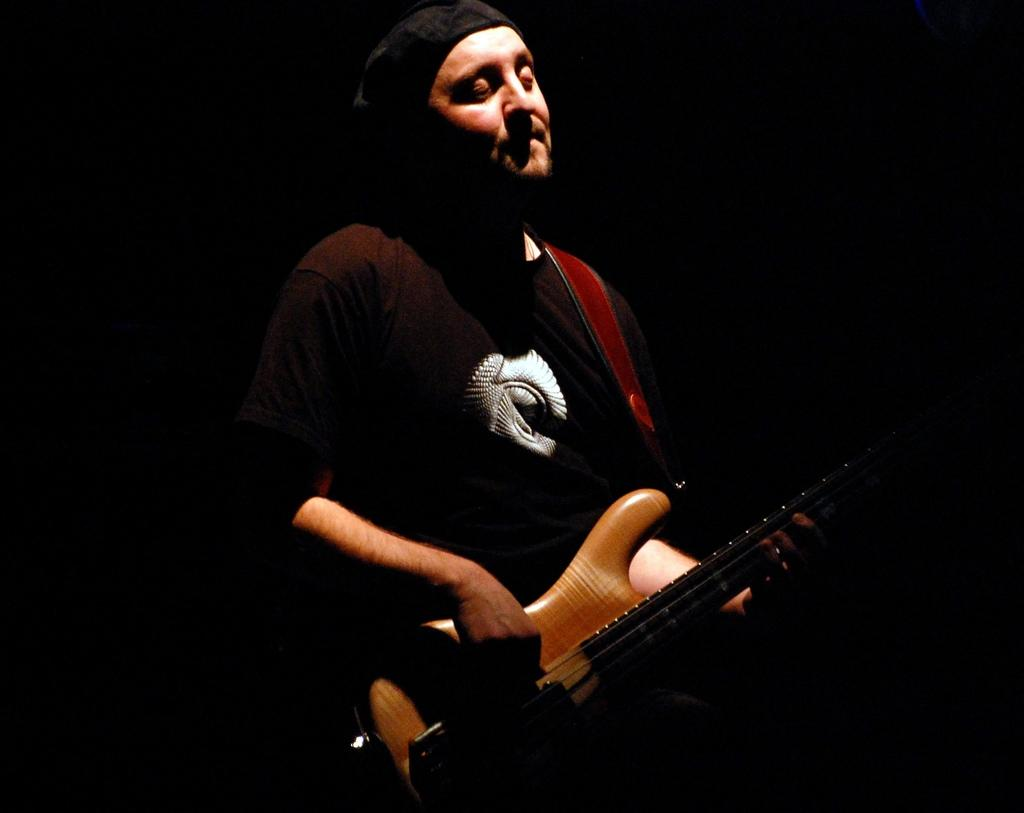What is the main subject of the image? There is a person in the image. What is the person wearing? The person is wearing a t-shirt. What is the person doing in the image? The person is standing and playing the guitar. What is the person holding in the image? The person is holding a guitar. What is the color of the background in the image? The background of the image is dark in color. What type of sign can be seen in the image? There is no sign present in the image. How much profit is the person making from playing the guitar in the image? There is no information about profit in the image, as it only shows a person playing a guitar. 